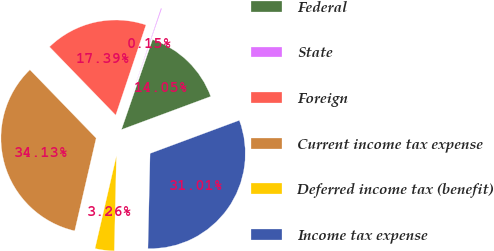<chart> <loc_0><loc_0><loc_500><loc_500><pie_chart><fcel>Federal<fcel>State<fcel>Foreign<fcel>Current income tax expense<fcel>Deferred income tax (benefit)<fcel>Income tax expense<nl><fcel>14.05%<fcel>0.15%<fcel>17.39%<fcel>34.13%<fcel>3.26%<fcel>31.01%<nl></chart> 